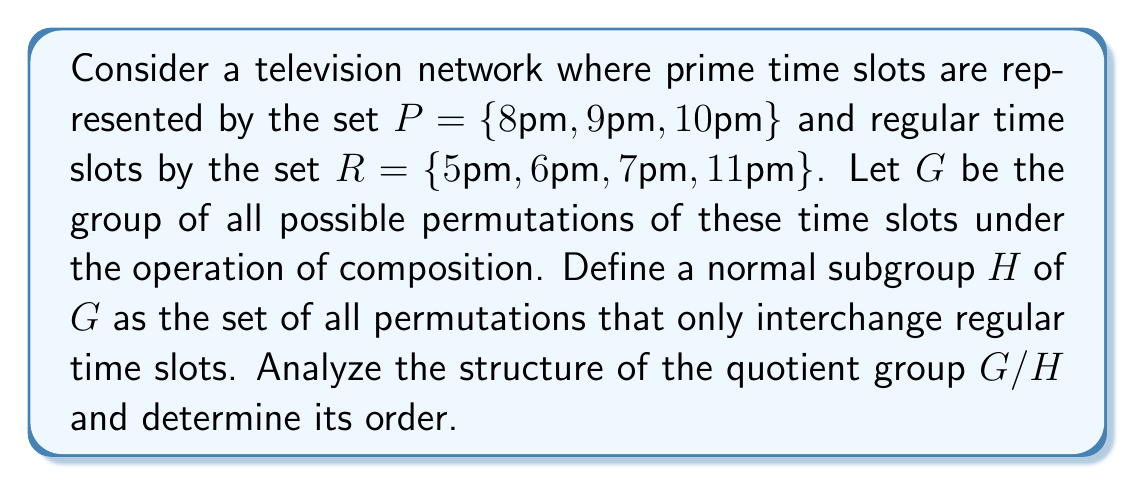Give your solution to this math problem. To analyze the structure of the quotient group $G/H$, we need to follow these steps:

1) First, let's determine the order of $G$:
   $|G| = 7!$ (permutations of all 7 time slots)

2) Now, let's determine the order of $H$:
   $|H| = 4!$ (permutations of only the 4 regular time slots)

3) By the Lagrange's theorem, we know that:
   $|G/H| = |G| / |H| = 7! / 4! = 210$

4) The elements of $G/H$ are the left cosets of $H$ in $G$. Each coset represents a unique way the prime time slots can be arranged among all slots, while the regular slots are free to be permuted among themselves.

5) We can think of each element in $G/H$ as a unique arrangement of the 3 prime time slots among the 7 total slots. This is equivalent to choosing 3 positions out of 7 for the prime time slots, which can be done in $\binom{7}{3} = 35$ ways.

6) Therefore, $G/H$ is isomorphic to the symmetric group $S_3$, which represents all possible permutations of the 3 prime time slots.

7) The structure of $S_3$ is well-known:
   - It has order 6
   - It is not abelian
   - It has a normal subgroup of order 3 (the alternating group $A_3$)

8) However, our $G/H$ has order 210, which is 35 times larger than $S_3$. This suggests that $G/H$ is isomorphic to the direct product of $S_3$ with a cyclic group of order 35:

   $G/H \cong S_3 \times \mathbb{Z}_{35}$

This structure reflects the fact that for each permutation of prime time slots (represented by $S_3$), there are 35 ways to distribute these permuted prime time slots among the 7 total slots.
Answer: The quotient group $G/H$ has order 210 and is isomorphic to $S_3 \times \mathbb{Z}_{35}$, where $S_3$ is the symmetric group on 3 elements and $\mathbb{Z}_{35}$ is the cyclic group of order 35. 